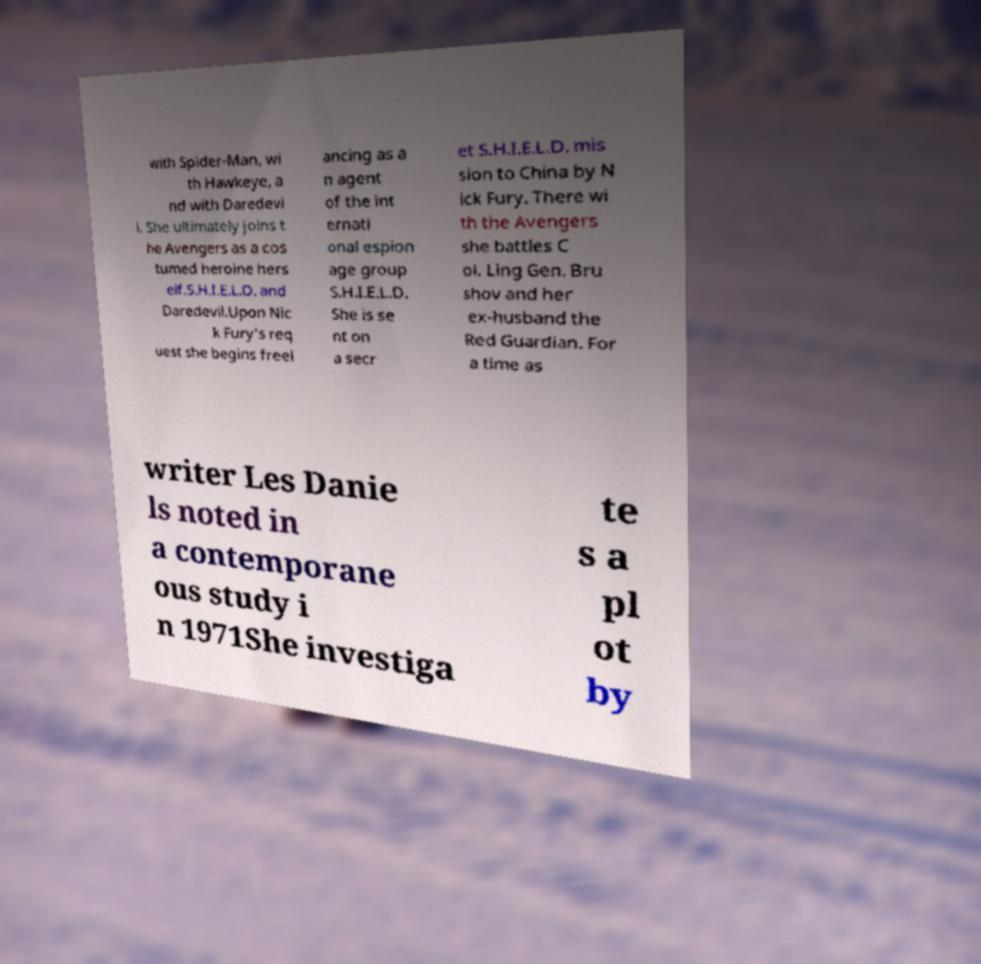Could you assist in decoding the text presented in this image and type it out clearly? with Spider-Man, wi th Hawkeye, a nd with Daredevi l. She ultimately joins t he Avengers as a cos tumed heroine hers elf.S.H.I.E.L.D. and Daredevil.Upon Nic k Fury's req uest she begins freel ancing as a n agent of the int ernati onal espion age group S.H.I.E.L.D. She is se nt on a secr et S.H.I.E.L.D. mis sion to China by N ick Fury. There wi th the Avengers she battles C ol. Ling Gen. Bru shov and her ex-husband the Red Guardian. For a time as writer Les Danie ls noted in a contemporane ous study i n 1971She investiga te s a pl ot by 